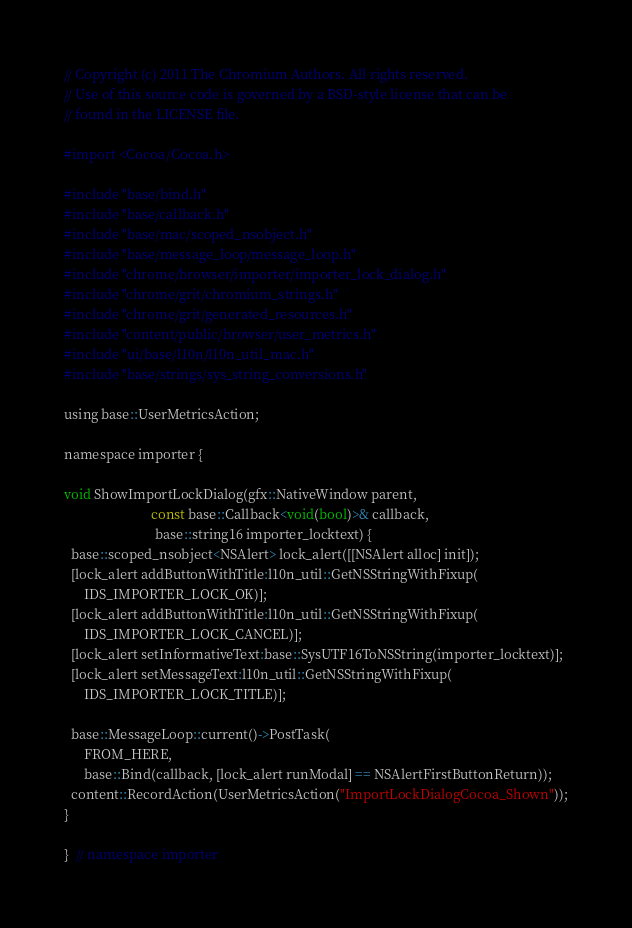<code> <loc_0><loc_0><loc_500><loc_500><_ObjectiveC_>// Copyright (c) 2011 The Chromium Authors. All rights reserved.
// Use of this source code is governed by a BSD-style license that can be
// found in the LICENSE file.

#import <Cocoa/Cocoa.h>

#include "base/bind.h"
#include "base/callback.h"
#include "base/mac/scoped_nsobject.h"
#include "base/message_loop/message_loop.h"
#include "chrome/browser/importer/importer_lock_dialog.h"
#include "chrome/grit/chromium_strings.h"
#include "chrome/grit/generated_resources.h"
#include "content/public/browser/user_metrics.h"
#include "ui/base/l10n/l10n_util_mac.h"
#include "base/strings/sys_string_conversions.h"

using base::UserMetricsAction;

namespace importer {

void ShowImportLockDialog(gfx::NativeWindow parent,
                          const base::Callback<void(bool)>& callback,
                           base::string16 importer_locktext) {
  base::scoped_nsobject<NSAlert> lock_alert([[NSAlert alloc] init]);
  [lock_alert addButtonWithTitle:l10n_util::GetNSStringWithFixup(
      IDS_IMPORTER_LOCK_OK)];
  [lock_alert addButtonWithTitle:l10n_util::GetNSStringWithFixup(
      IDS_IMPORTER_LOCK_CANCEL)];
  [lock_alert setInformativeText:base::SysUTF16ToNSString(importer_locktext)];
  [lock_alert setMessageText:l10n_util::GetNSStringWithFixup(
      IDS_IMPORTER_LOCK_TITLE)];

  base::MessageLoop::current()->PostTask(
      FROM_HERE,
      base::Bind(callback, [lock_alert runModal] == NSAlertFirstButtonReturn));
  content::RecordAction(UserMetricsAction("ImportLockDialogCocoa_Shown"));
}

}  // namespace importer
</code> 